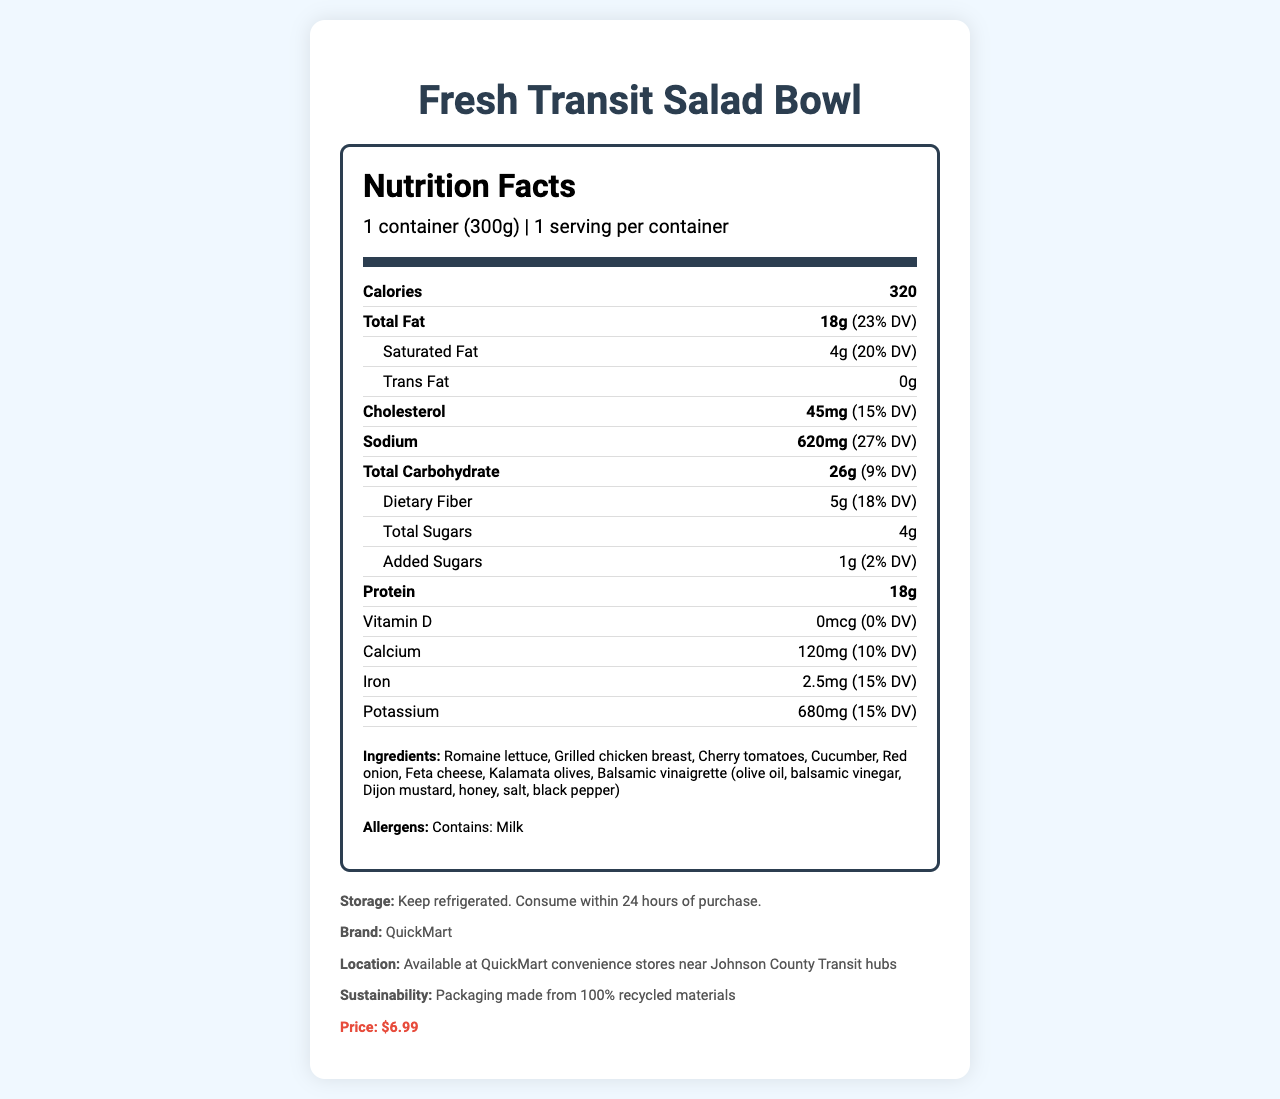what is the serving size of the Fresh Transit Salad Bowl? The serving size is stated at the top of the nutrition label under the product name as "1 container (300g)".
Answer: 1 container (300g) how many grams of total fat does the salad contain? The total fat content is listed as 18g under the 'Total Fat' section of the nutrition label.
Answer: 18g what amount of dietary fiber is in one serving of the salad? The dietary fiber content can be found under the 'Total Carbohydrate' section, where it states 5g.
Answer: 5g what is the percentage daily value for cholesterol in the salad? The percentage daily value for cholesterol is listed as 15% next to the cholesterol amount of 45mg.
Answer: 15% what is the price of the Fresh Transit Salad Bowl? The price is listed at the bottom of the document in the product info section under "Price:".
Answer: $6.99 what is the protein content in one container of the salad? A. 10g B. 15g C. 18g D. 20g The protein content is listed as 18g under the 'Protein' section of the nutrition label.
Answer: C. 18g which ingredient is not listed in the salad? i. Romaine lettuce ii. Grilled chicken breast iii. Carrots iv. Feta cheese Carrots are not listed among the ingredients which include Romaine lettuce, Grilled chicken breast, Cherry tomatoes, Cucumber, Red onion, Feta cheese, Kalamata olives, and Balsamic vinaigrette.
Answer: iii. Carrots does the salad contain any allergens? The document specifies that the salad contains milk under the "Allergens" section.
Answer: Yes summarize the main nutritional characteristics of the Fresh Transit Salad Bowl The summary should encapsulate all the critical nutritional data and relevant product information like unique ingredients, allergens, and price.
Answer: The Fresh Transit Salad Bowl is a ready-to-eat salad that contains 320 calories per container. It has 18g of total fat, including 4g of saturated fat, and no trans fat. It also contains 45mg of cholesterol, 620mg of sodium, 26g of total carbohydrates including 5g of dietary fiber and 4g of total sugars, with 18g of protein. The ingredients include Romaine lettuce, grilled chicken breast, cherry tomatoes, cucumber, red onion, feta cheese, Kalamata olives, and balsamic vinaigrette. The salad contains milk as an allergen and is priced at $6.99. Does the salad contain any iron? The document lists the iron content as 2.5mg with a 15% daily value.
Answer: Yes what type of packaging is used for the salad? The sustainability section mentions that the packaging is made from 100% recycled materials.
Answer: 100% recycled materials what is the brand of the salad? The brand of the salad is mentioned in the product info section as "QuickMart".
Answer: QuickMart are there any instructions for storing the salad? The storage instructions are given as "Keep refrigerated. Consume within 24 hours of purchase."
Answer: Yes Can the salad be found at the grocery store near Johnson County? The document specifies that the salad is available at QuickMart convenience stores near Johnson County Transit hubs, but it does not provide information about availability at grocery stores.
Answer: Cannot be determined what would be the daily value percentage for total carbohydrates if a person consumes the salad? The daily value percentage for total carbohydrates is listed as 9% in the nutrition facts.
Answer: 9% how many grams of added sugars are in the salad? The added sugars content is listed as 1g under the 'Total Carbohydrate' section of the nutrition label.
Answer: 1g 